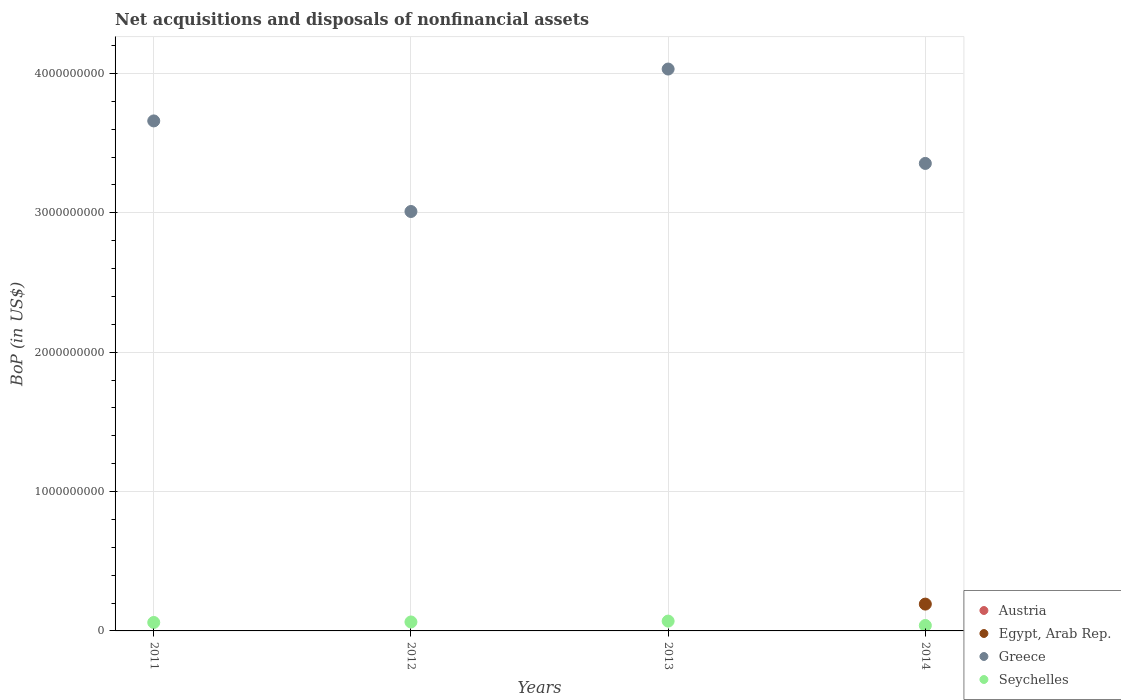How many different coloured dotlines are there?
Provide a short and direct response. 3. Is the number of dotlines equal to the number of legend labels?
Offer a terse response. No. What is the Balance of Payments in Greece in 2011?
Offer a very short reply. 3.66e+09. Across all years, what is the maximum Balance of Payments in Egypt, Arab Rep.?
Provide a succinct answer. 1.92e+08. What is the total Balance of Payments in Austria in the graph?
Ensure brevity in your answer.  0. What is the difference between the Balance of Payments in Seychelles in 2012 and that in 2014?
Ensure brevity in your answer.  2.51e+07. What is the difference between the Balance of Payments in Austria in 2011 and the Balance of Payments in Seychelles in 2014?
Your answer should be very brief. -3.91e+07. What is the average Balance of Payments in Egypt, Arab Rep. per year?
Your answer should be very brief. 4.81e+07. In the year 2012, what is the difference between the Balance of Payments in Seychelles and Balance of Payments in Greece?
Give a very brief answer. -2.95e+09. What is the ratio of the Balance of Payments in Seychelles in 2011 to that in 2012?
Provide a short and direct response. 0.95. Is the Balance of Payments in Seychelles in 2011 less than that in 2013?
Offer a terse response. Yes. What is the difference between the highest and the second highest Balance of Payments in Seychelles?
Your answer should be very brief. 6.34e+06. What is the difference between the highest and the lowest Balance of Payments in Greece?
Your answer should be very brief. 1.02e+09. Is it the case that in every year, the sum of the Balance of Payments in Greece and Balance of Payments in Austria  is greater than the Balance of Payments in Egypt, Arab Rep.?
Your answer should be very brief. Yes. Does the Balance of Payments in Seychelles monotonically increase over the years?
Your response must be concise. No. Is the Balance of Payments in Egypt, Arab Rep. strictly less than the Balance of Payments in Austria over the years?
Your answer should be compact. No. How many dotlines are there?
Keep it short and to the point. 3. What is the difference between two consecutive major ticks on the Y-axis?
Your response must be concise. 1.00e+09. Does the graph contain any zero values?
Your answer should be compact. Yes. Does the graph contain grids?
Provide a succinct answer. Yes. Where does the legend appear in the graph?
Provide a short and direct response. Bottom right. What is the title of the graph?
Provide a short and direct response. Net acquisitions and disposals of nonfinancial assets. What is the label or title of the X-axis?
Provide a succinct answer. Years. What is the label or title of the Y-axis?
Keep it short and to the point. BoP (in US$). What is the BoP (in US$) of Greece in 2011?
Your answer should be compact. 3.66e+09. What is the BoP (in US$) in Seychelles in 2011?
Make the answer very short. 6.06e+07. What is the BoP (in US$) in Austria in 2012?
Make the answer very short. 0. What is the BoP (in US$) of Greece in 2012?
Offer a very short reply. 3.01e+09. What is the BoP (in US$) in Seychelles in 2012?
Provide a short and direct response. 6.42e+07. What is the BoP (in US$) in Austria in 2013?
Give a very brief answer. 0. What is the BoP (in US$) in Egypt, Arab Rep. in 2013?
Your answer should be compact. 0. What is the BoP (in US$) in Greece in 2013?
Make the answer very short. 4.03e+09. What is the BoP (in US$) of Seychelles in 2013?
Provide a short and direct response. 7.05e+07. What is the BoP (in US$) in Egypt, Arab Rep. in 2014?
Offer a terse response. 1.92e+08. What is the BoP (in US$) of Greece in 2014?
Keep it short and to the point. 3.35e+09. What is the BoP (in US$) in Seychelles in 2014?
Give a very brief answer. 3.91e+07. Across all years, what is the maximum BoP (in US$) in Egypt, Arab Rep.?
Provide a short and direct response. 1.92e+08. Across all years, what is the maximum BoP (in US$) in Greece?
Offer a terse response. 4.03e+09. Across all years, what is the maximum BoP (in US$) of Seychelles?
Provide a short and direct response. 7.05e+07. Across all years, what is the minimum BoP (in US$) of Egypt, Arab Rep.?
Make the answer very short. 0. Across all years, what is the minimum BoP (in US$) of Greece?
Make the answer very short. 3.01e+09. Across all years, what is the minimum BoP (in US$) of Seychelles?
Keep it short and to the point. 3.91e+07. What is the total BoP (in US$) in Austria in the graph?
Keep it short and to the point. 0. What is the total BoP (in US$) of Egypt, Arab Rep. in the graph?
Your answer should be very brief. 1.92e+08. What is the total BoP (in US$) in Greece in the graph?
Your answer should be compact. 1.41e+1. What is the total BoP (in US$) of Seychelles in the graph?
Provide a short and direct response. 2.34e+08. What is the difference between the BoP (in US$) of Greece in 2011 and that in 2012?
Offer a very short reply. 6.50e+08. What is the difference between the BoP (in US$) in Seychelles in 2011 and that in 2012?
Offer a terse response. -3.52e+06. What is the difference between the BoP (in US$) in Greece in 2011 and that in 2013?
Give a very brief answer. -3.72e+08. What is the difference between the BoP (in US$) in Seychelles in 2011 and that in 2013?
Give a very brief answer. -9.86e+06. What is the difference between the BoP (in US$) in Greece in 2011 and that in 2014?
Give a very brief answer. 3.05e+08. What is the difference between the BoP (in US$) of Seychelles in 2011 and that in 2014?
Provide a short and direct response. 2.16e+07. What is the difference between the BoP (in US$) of Greece in 2012 and that in 2013?
Your answer should be compact. -1.02e+09. What is the difference between the BoP (in US$) in Seychelles in 2012 and that in 2013?
Your response must be concise. -6.34e+06. What is the difference between the BoP (in US$) in Greece in 2012 and that in 2014?
Make the answer very short. -3.45e+08. What is the difference between the BoP (in US$) of Seychelles in 2012 and that in 2014?
Offer a very short reply. 2.51e+07. What is the difference between the BoP (in US$) in Greece in 2013 and that in 2014?
Your answer should be compact. 6.77e+08. What is the difference between the BoP (in US$) in Seychelles in 2013 and that in 2014?
Ensure brevity in your answer.  3.14e+07. What is the difference between the BoP (in US$) of Greece in 2011 and the BoP (in US$) of Seychelles in 2012?
Your answer should be compact. 3.60e+09. What is the difference between the BoP (in US$) of Greece in 2011 and the BoP (in US$) of Seychelles in 2013?
Offer a terse response. 3.59e+09. What is the difference between the BoP (in US$) in Greece in 2011 and the BoP (in US$) in Seychelles in 2014?
Your answer should be very brief. 3.62e+09. What is the difference between the BoP (in US$) of Greece in 2012 and the BoP (in US$) of Seychelles in 2013?
Provide a succinct answer. 2.94e+09. What is the difference between the BoP (in US$) of Greece in 2012 and the BoP (in US$) of Seychelles in 2014?
Provide a short and direct response. 2.97e+09. What is the difference between the BoP (in US$) of Greece in 2013 and the BoP (in US$) of Seychelles in 2014?
Your answer should be very brief. 3.99e+09. What is the average BoP (in US$) of Austria per year?
Offer a terse response. 0. What is the average BoP (in US$) in Egypt, Arab Rep. per year?
Provide a short and direct response. 4.81e+07. What is the average BoP (in US$) of Greece per year?
Ensure brevity in your answer.  3.51e+09. What is the average BoP (in US$) in Seychelles per year?
Offer a terse response. 5.86e+07. In the year 2011, what is the difference between the BoP (in US$) in Greece and BoP (in US$) in Seychelles?
Provide a short and direct response. 3.60e+09. In the year 2012, what is the difference between the BoP (in US$) in Greece and BoP (in US$) in Seychelles?
Keep it short and to the point. 2.95e+09. In the year 2013, what is the difference between the BoP (in US$) of Greece and BoP (in US$) of Seychelles?
Offer a terse response. 3.96e+09. In the year 2014, what is the difference between the BoP (in US$) of Egypt, Arab Rep. and BoP (in US$) of Greece?
Provide a succinct answer. -3.16e+09. In the year 2014, what is the difference between the BoP (in US$) in Egypt, Arab Rep. and BoP (in US$) in Seychelles?
Ensure brevity in your answer.  1.53e+08. In the year 2014, what is the difference between the BoP (in US$) in Greece and BoP (in US$) in Seychelles?
Make the answer very short. 3.32e+09. What is the ratio of the BoP (in US$) of Greece in 2011 to that in 2012?
Ensure brevity in your answer.  1.22. What is the ratio of the BoP (in US$) of Seychelles in 2011 to that in 2012?
Your answer should be compact. 0.95. What is the ratio of the BoP (in US$) of Greece in 2011 to that in 2013?
Your answer should be very brief. 0.91. What is the ratio of the BoP (in US$) of Seychelles in 2011 to that in 2013?
Your answer should be compact. 0.86. What is the ratio of the BoP (in US$) of Greece in 2011 to that in 2014?
Provide a succinct answer. 1.09. What is the ratio of the BoP (in US$) of Seychelles in 2011 to that in 2014?
Ensure brevity in your answer.  1.55. What is the ratio of the BoP (in US$) of Greece in 2012 to that in 2013?
Your answer should be compact. 0.75. What is the ratio of the BoP (in US$) in Seychelles in 2012 to that in 2013?
Your answer should be compact. 0.91. What is the ratio of the BoP (in US$) of Greece in 2012 to that in 2014?
Your answer should be very brief. 0.9. What is the ratio of the BoP (in US$) in Seychelles in 2012 to that in 2014?
Ensure brevity in your answer.  1.64. What is the ratio of the BoP (in US$) of Greece in 2013 to that in 2014?
Make the answer very short. 1.2. What is the ratio of the BoP (in US$) in Seychelles in 2013 to that in 2014?
Make the answer very short. 1.81. What is the difference between the highest and the second highest BoP (in US$) of Greece?
Keep it short and to the point. 3.72e+08. What is the difference between the highest and the second highest BoP (in US$) of Seychelles?
Your answer should be very brief. 6.34e+06. What is the difference between the highest and the lowest BoP (in US$) of Egypt, Arab Rep.?
Keep it short and to the point. 1.92e+08. What is the difference between the highest and the lowest BoP (in US$) of Greece?
Make the answer very short. 1.02e+09. What is the difference between the highest and the lowest BoP (in US$) of Seychelles?
Your answer should be very brief. 3.14e+07. 